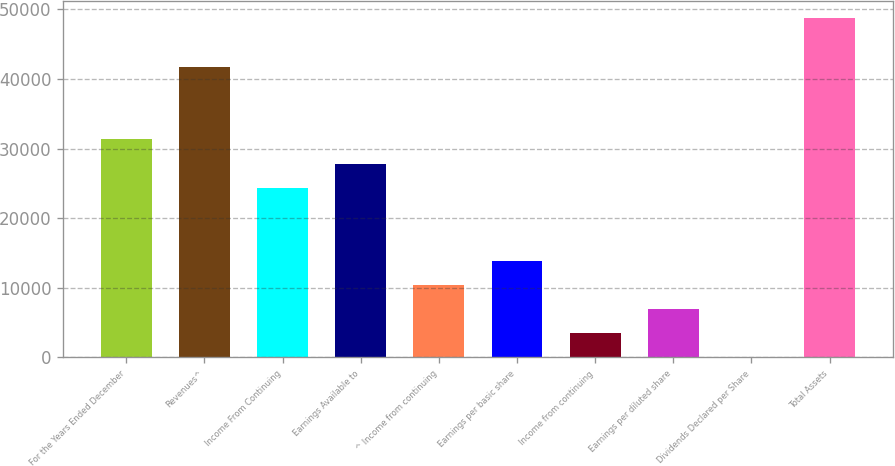<chart> <loc_0><loc_0><loc_500><loc_500><bar_chart><fcel>For the Years Ended December<fcel>Revenues^<fcel>Income From Continuing<fcel>Earnings Available to<fcel>^ Income from continuing<fcel>Earnings per basic share<fcel>Income from continuing<fcel>Earnings per diluted share<fcel>Dividends Declared per Share<fcel>Total Assets<nl><fcel>31324.7<fcel>41765.6<fcel>24364.2<fcel>27844.4<fcel>10443<fcel>13923.3<fcel>3482.48<fcel>6962.76<fcel>2.2<fcel>48726.1<nl></chart> 